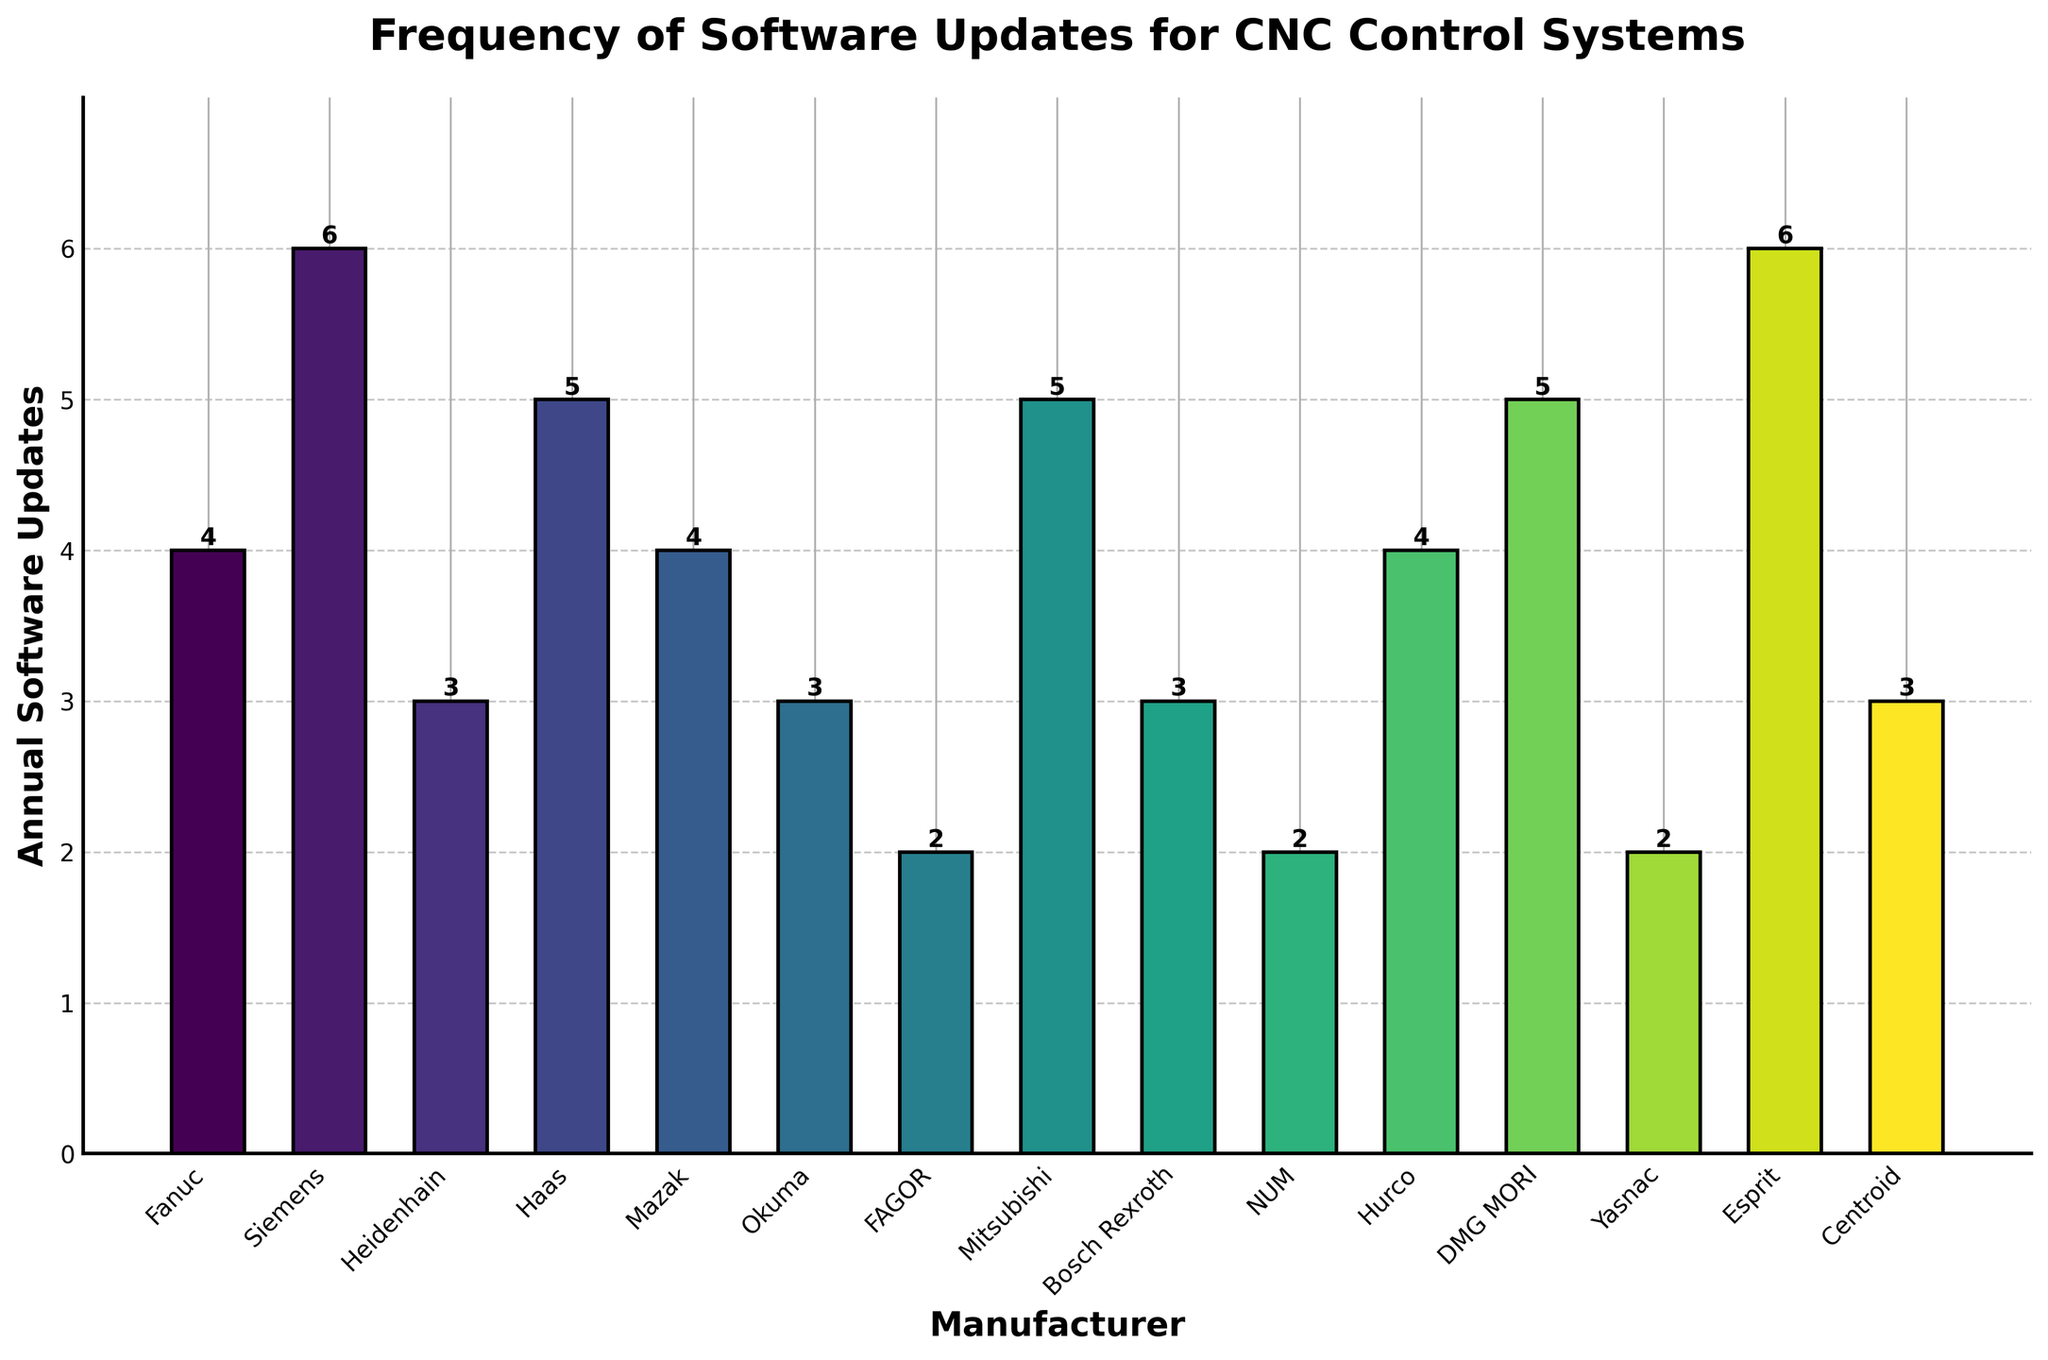What is the manufacturer with the highest number of annual software updates? Look at the heights of the bars and identify the tallest one. Siemens and Esprit both have the highest number of annual software updates at 6 each.
Answer: Siemens and Esprit Which manufacturers have fewer than 4 annual software updates? Identify the bars with heights less than 4. Fagor, NUM, Yasnac each have 2 updates, and Okuma, Bosch Rexroth, Heidenhain, and Centroid each have 3 updates.
Answer: Fagor, NUM, Yasnac, Okuma, Bosch Rexroth, Heidenhain, Centroid Among Fanuc, Haas, and Hurco, which manufacturer has the most annual software updates? Compare the heights of the bars for Fanuc, Haas, and Hurco. Haas has the most with 5 updates.
Answer: Haas What is the total number of software updates for Fanuc and Mazak combined? Add the number of updates for Fanuc (4) and Mazak (4). 4 + 4 equals 8.
Answer: 8 How many manufacturers have exactly 3 annual software updates? Count the number of bars with a height of 3. Heidenhain, Okuma, Bosch Rexroth, and Centroid each have 3 updates, giving a total of 4 manufacturers.
Answer: 4 What is the difference in the number of annual software updates between Siemens and Hurco? Subtract the number of updates for Hurco (4) from Siemens (6). 6 - 4 equals 2.
Answer: 2 Which manufacturers have the same number of annual software updates as Haas? Look for bars with the same height as Haas, which has 5 updates. Mitsubishi and DMG MORI also have 5 updates.
Answer: Mitsubishi, DMG MORI Which manufacturer has the lowest frequency of software updates? Identify the bars with the lowest height. Fagor, NUM, and Yasnac each have the lowest number of annual software updates with 2.
Answer: Fagor, NUM, Yasnac What is the average number of annual software updates across all manufacturers? Sum the updates (4 + 6 + 3 + 5 + 4 + 3 + 2 + 5 + 3 + 2 + 4 + 5 + 2 + 6 + 3) which equals 57, and divide by the number of manufacturers (15). 57 / 15 equals 3.8.
Answer: 3.8 